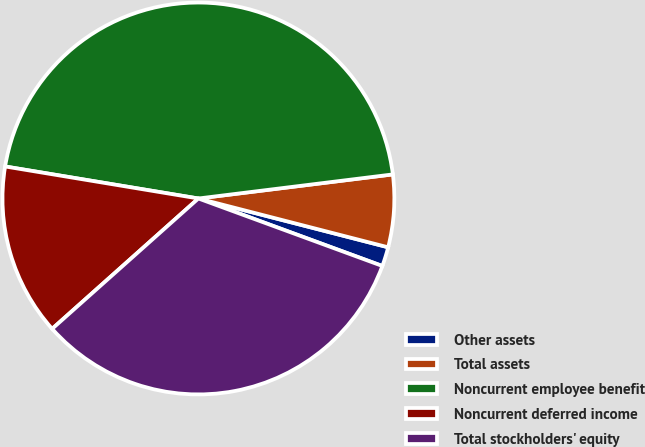Convert chart to OTSL. <chart><loc_0><loc_0><loc_500><loc_500><pie_chart><fcel>Other assets<fcel>Total assets<fcel>Noncurrent employee benefit<fcel>Noncurrent deferred income<fcel>Total stockholders' equity<nl><fcel>1.59%<fcel>5.97%<fcel>45.43%<fcel>14.2%<fcel>32.82%<nl></chart> 